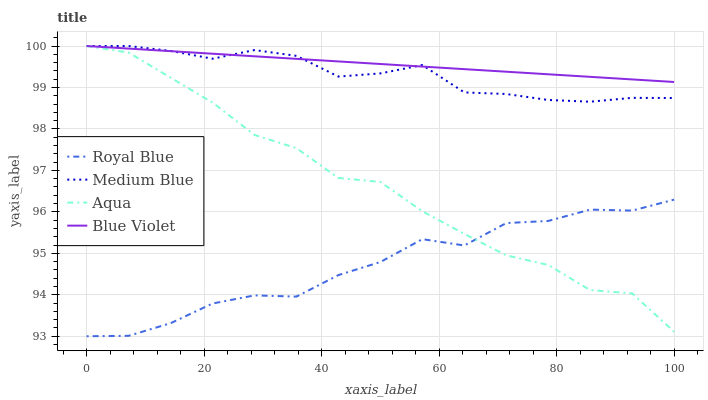Does Royal Blue have the minimum area under the curve?
Answer yes or no. Yes. Does Blue Violet have the maximum area under the curve?
Answer yes or no. Yes. Does Medium Blue have the minimum area under the curve?
Answer yes or no. No. Does Medium Blue have the maximum area under the curve?
Answer yes or no. No. Is Blue Violet the smoothest?
Answer yes or no. Yes. Is Aqua the roughest?
Answer yes or no. Yes. Is Royal Blue the smoothest?
Answer yes or no. No. Is Royal Blue the roughest?
Answer yes or no. No. Does Royal Blue have the lowest value?
Answer yes or no. Yes. Does Medium Blue have the lowest value?
Answer yes or no. No. Does Blue Violet have the highest value?
Answer yes or no. Yes. Does Royal Blue have the highest value?
Answer yes or no. No. Is Royal Blue less than Blue Violet?
Answer yes or no. Yes. Is Medium Blue greater than Aqua?
Answer yes or no. Yes. Does Royal Blue intersect Aqua?
Answer yes or no. Yes. Is Royal Blue less than Aqua?
Answer yes or no. No. Is Royal Blue greater than Aqua?
Answer yes or no. No. Does Royal Blue intersect Blue Violet?
Answer yes or no. No. 